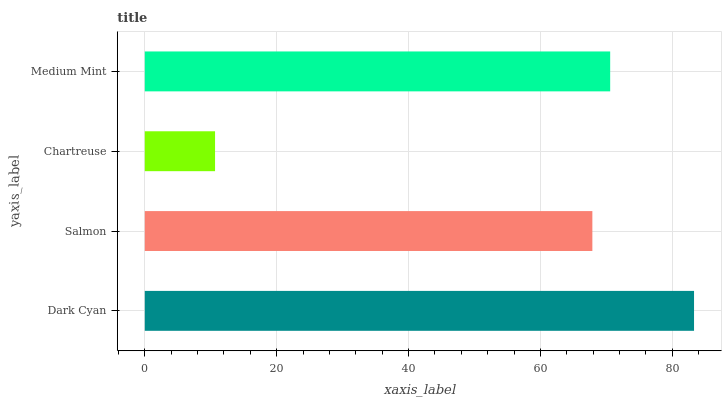Is Chartreuse the minimum?
Answer yes or no. Yes. Is Dark Cyan the maximum?
Answer yes or no. Yes. Is Salmon the minimum?
Answer yes or no. No. Is Salmon the maximum?
Answer yes or no. No. Is Dark Cyan greater than Salmon?
Answer yes or no. Yes. Is Salmon less than Dark Cyan?
Answer yes or no. Yes. Is Salmon greater than Dark Cyan?
Answer yes or no. No. Is Dark Cyan less than Salmon?
Answer yes or no. No. Is Medium Mint the high median?
Answer yes or no. Yes. Is Salmon the low median?
Answer yes or no. Yes. Is Salmon the high median?
Answer yes or no. No. Is Dark Cyan the low median?
Answer yes or no. No. 